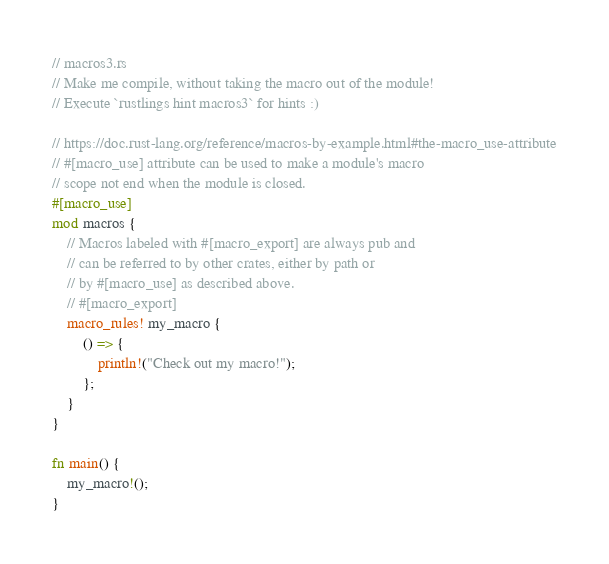<code> <loc_0><loc_0><loc_500><loc_500><_Rust_>// macros3.rs
// Make me compile, without taking the macro out of the module!
// Execute `rustlings hint macros3` for hints :)

// https://doc.rust-lang.org/reference/macros-by-example.html#the-macro_use-attribute
// #[macro_use] attribute can be used to make a module's macro
// scope not end when the module is closed.
#[macro_use]
mod macros {
    // Macros labeled with #[macro_export] are always pub and
    // can be referred to by other crates, either by path or
    // by #[macro_use] as described above.
    // #[macro_export]
    macro_rules! my_macro {
        () => {
            println!("Check out my macro!");
        };
    }
}

fn main() {
    my_macro!();
}
</code> 